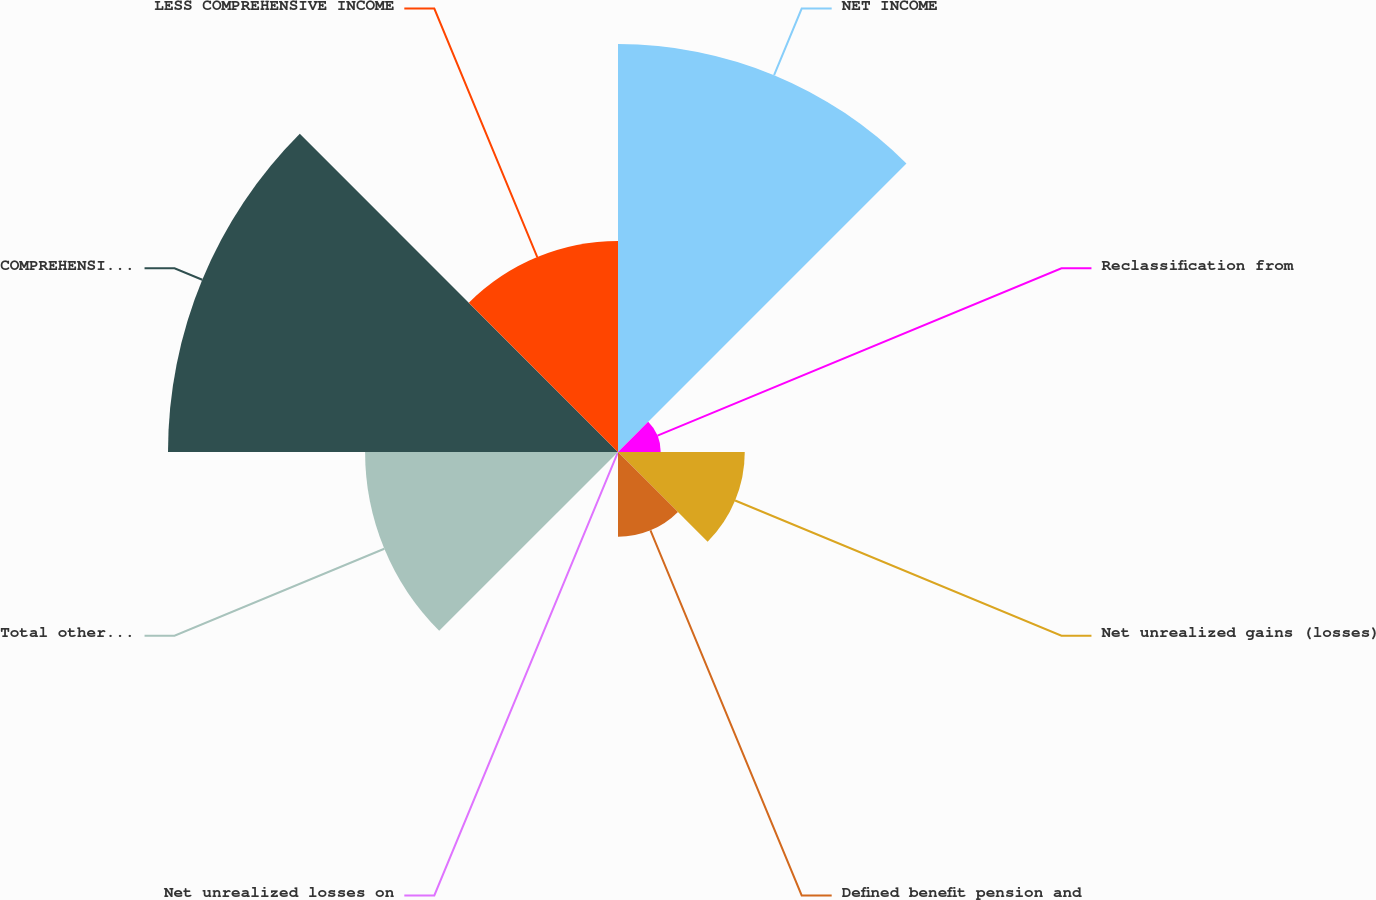<chart> <loc_0><loc_0><loc_500><loc_500><pie_chart><fcel>NET INCOME<fcel>Reclassification from<fcel>Net unrealized gains (losses)<fcel>Defined benefit pension and<fcel>Net unrealized losses on<fcel>Total other comprehensive<fcel>COMPREHENSIVE INCOME<fcel>LESS COMPREHENSIVE INCOME<nl><fcel>25.87%<fcel>2.71%<fcel>8.04%<fcel>5.38%<fcel>0.04%<fcel>16.04%<fcel>28.54%<fcel>13.38%<nl></chart> 